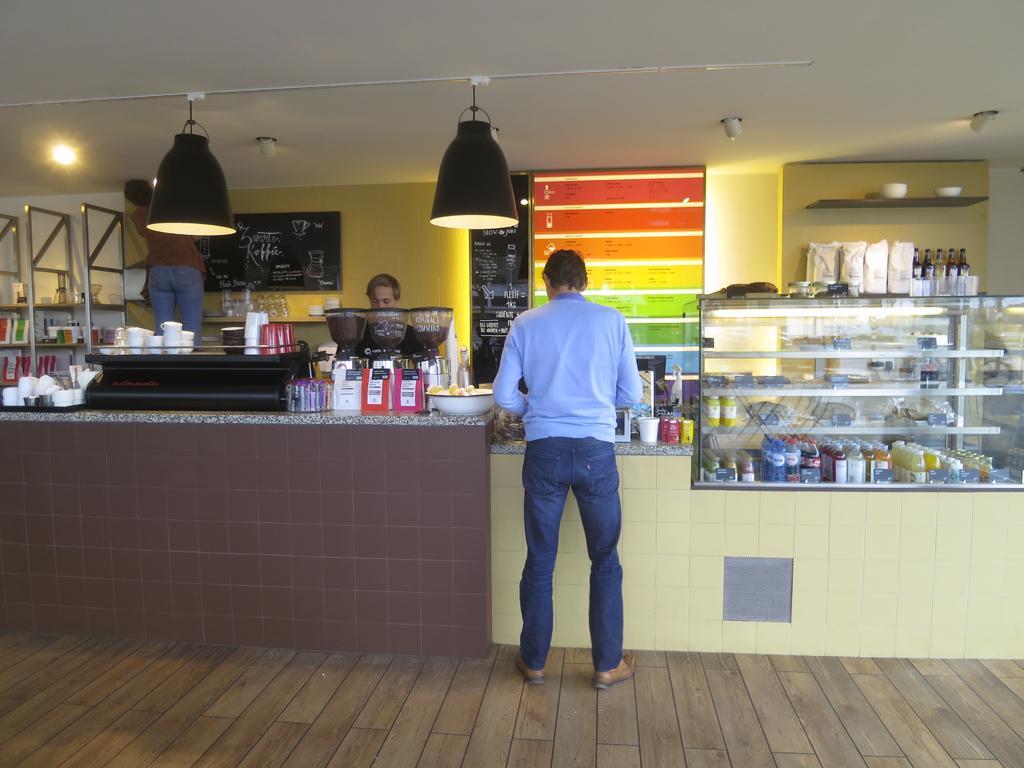Can you describe this image briefly? In the picture I can see 3 people among them the person who is standing in front of the image is wearing blue color clothes and shoes. I can also see bottles, glasses, cups and some other objects on a platform. In the background I can see lights on the ceiling, wall which are some objects attached to it and some other objects on shelf. 